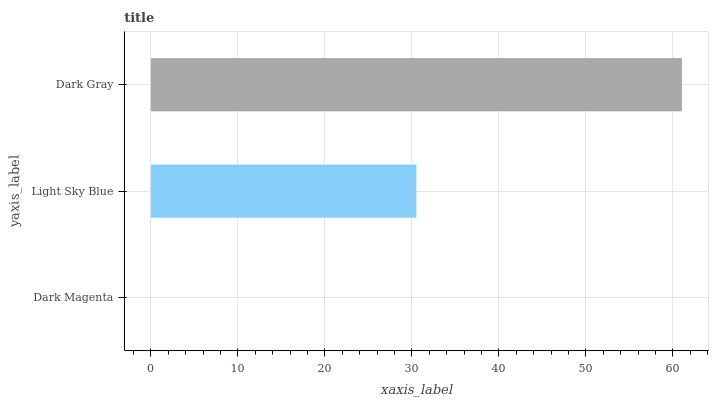Is Dark Magenta the minimum?
Answer yes or no. Yes. Is Dark Gray the maximum?
Answer yes or no. Yes. Is Light Sky Blue the minimum?
Answer yes or no. No. Is Light Sky Blue the maximum?
Answer yes or no. No. Is Light Sky Blue greater than Dark Magenta?
Answer yes or no. Yes. Is Dark Magenta less than Light Sky Blue?
Answer yes or no. Yes. Is Dark Magenta greater than Light Sky Blue?
Answer yes or no. No. Is Light Sky Blue less than Dark Magenta?
Answer yes or no. No. Is Light Sky Blue the high median?
Answer yes or no. Yes. Is Light Sky Blue the low median?
Answer yes or no. Yes. Is Dark Gray the high median?
Answer yes or no. No. Is Dark Magenta the low median?
Answer yes or no. No. 